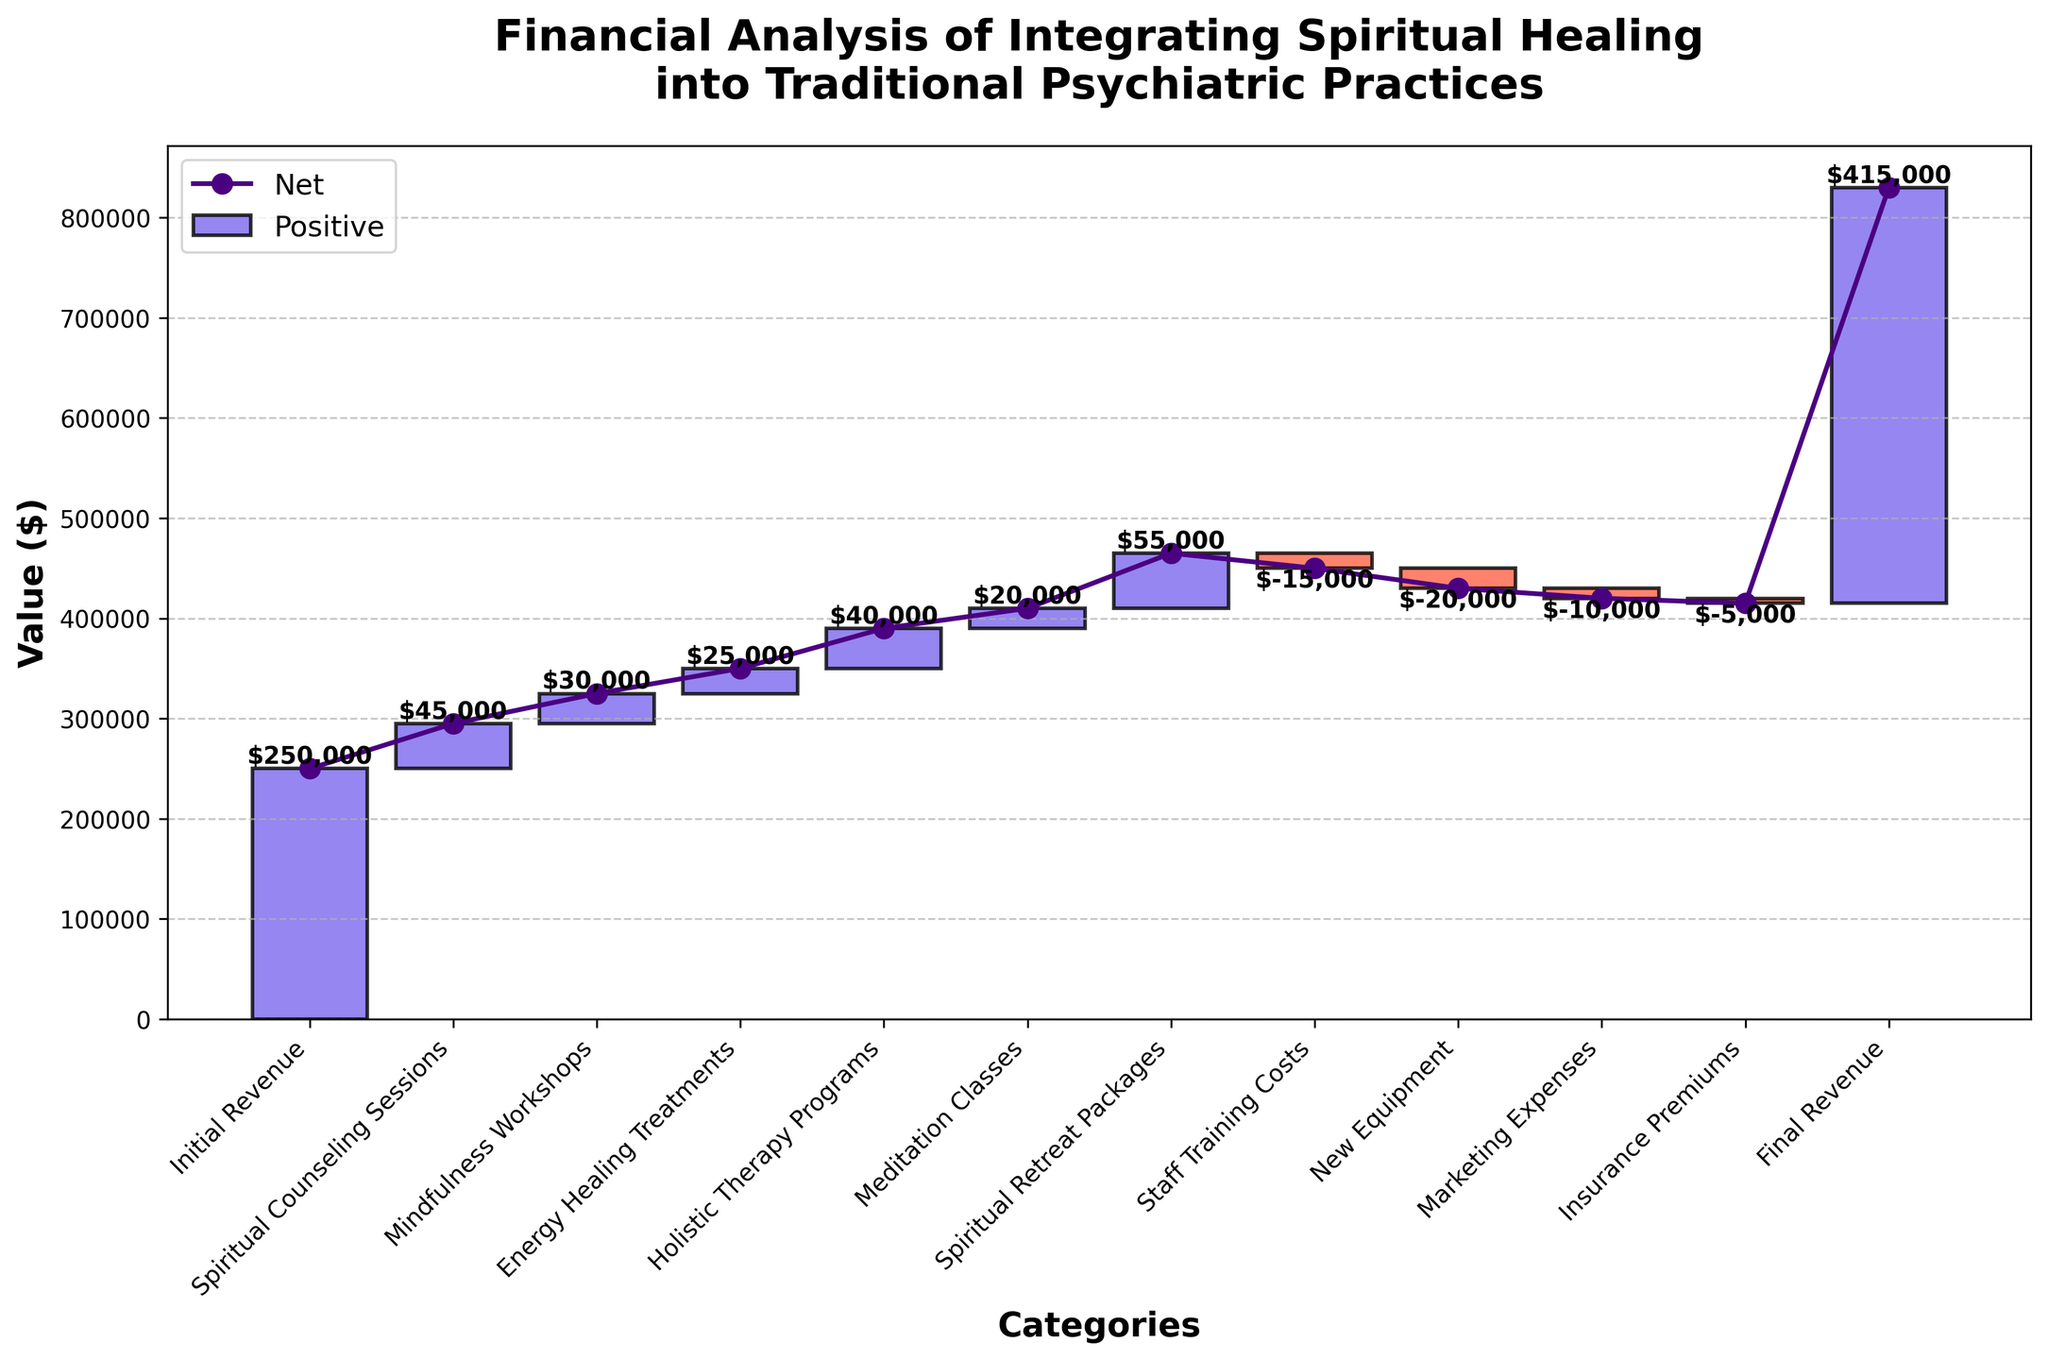What is the title of the chart? The title of the chart is located at the top and summarizes the main focus of the visual.
Answer: Financial Analysis of Integrating Spiritual Healing into Traditional Psychiatric Practices How many categories are represented in the chart? By counting the data points, one can enumerate the distinct categories represented on the x-axis of the chart.
Answer: 11 What is the value associated with "Spiritual Counseling Sessions"? The chart displays the value of each category above the respective bars. Locate the bar labeled "Spiritual Counseling Sessions" to find the value.
Answer: $45,000 Which category had the highest positive value addition to revenue? To find the category with the highest positive addition, compare the height of the positive bars and their associated values. "Spiritual Retreat Packages" has the highest value.
Answer: Spiritual Retreat Packages How does the final revenue compare to the initial revenue? To compare, subtract the initial revenue from the final revenue. The initial revenue is $250,000, and the final revenue is $415,000. So, $415,000 - $250,000 = $165,000.
Answer: The final revenue increased by $165,000 What is the combined revenue contribution of Mindfulness Workshops and Energy Healing Treatments? Sum the values of these two categories. Mindfulness Workshops ($30,000) and Energy Healing Treatments ($25,000) yield $30,000 + $25,000 = $55,000.
Answer: $55,000 What is the net effect on revenue due to "New Equipment" and "Marketing Expenses"? Add the negative values for these categories. New Equipment is -$20,000, and Marketing Expenses is -$10,000. The net effect is -$20,000 + -$10,000 = -$30,000.
Answer: -$30,000 Which category had the least impact on increasing the revenue? Among positive contributions, the category with the smallest value has the least impact. "Meditation Classes" added $20,000, which is the smallest positive value.
Answer: Meditation Classes What is the total value of all expense categories in the chart? Sum the values of all expense categories shown in red. Staff Training Costs: -$15,000, New Equipment: -$20,000, Marketing Expenses: -$10,000, Insurance Premiums: -$5,000. Total: -$15,000 + -$20,000 + -$10,000 + -$5,000 = -$50,000.
Answer: -$50,000 What percentage of the total revenue increase is contributed by "Spiritual Counseling Sessions"? First, calculate the total revenue increase, which is $415,000 - $250,000 = $165,000. Then, determine the percentage contributed by Spiritual Counseling Sessions: ($45,000 / $165,000) * 100 = 27.27%.
Answer: 27.27% 